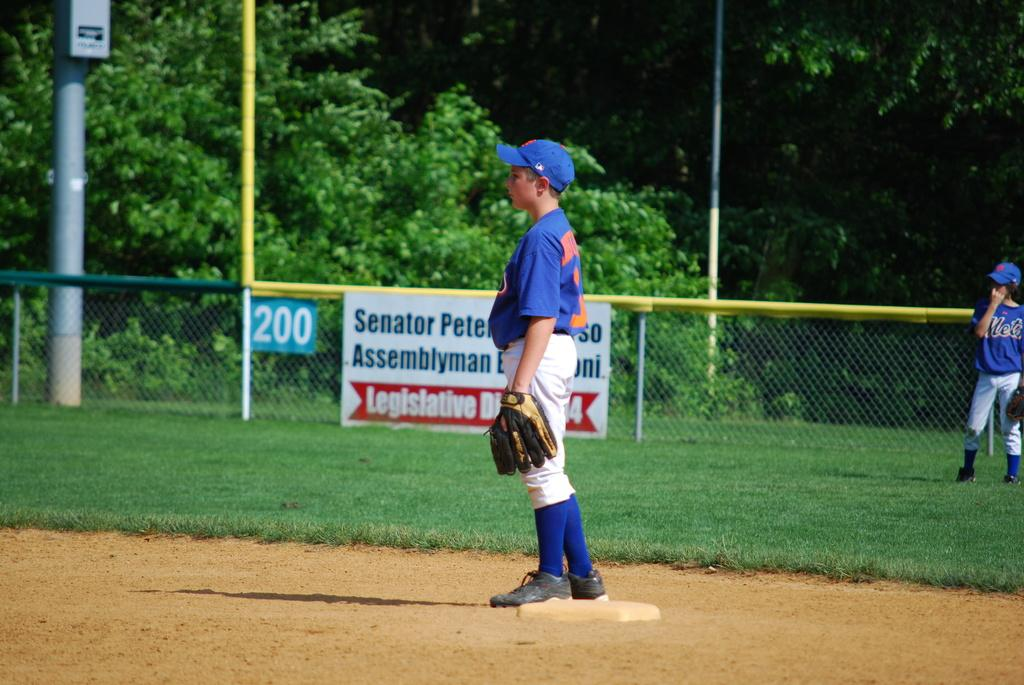<image>
Share a concise interpretation of the image provided. A little league player stands on base with a sign for a Senator Assemblyman on the fence. 